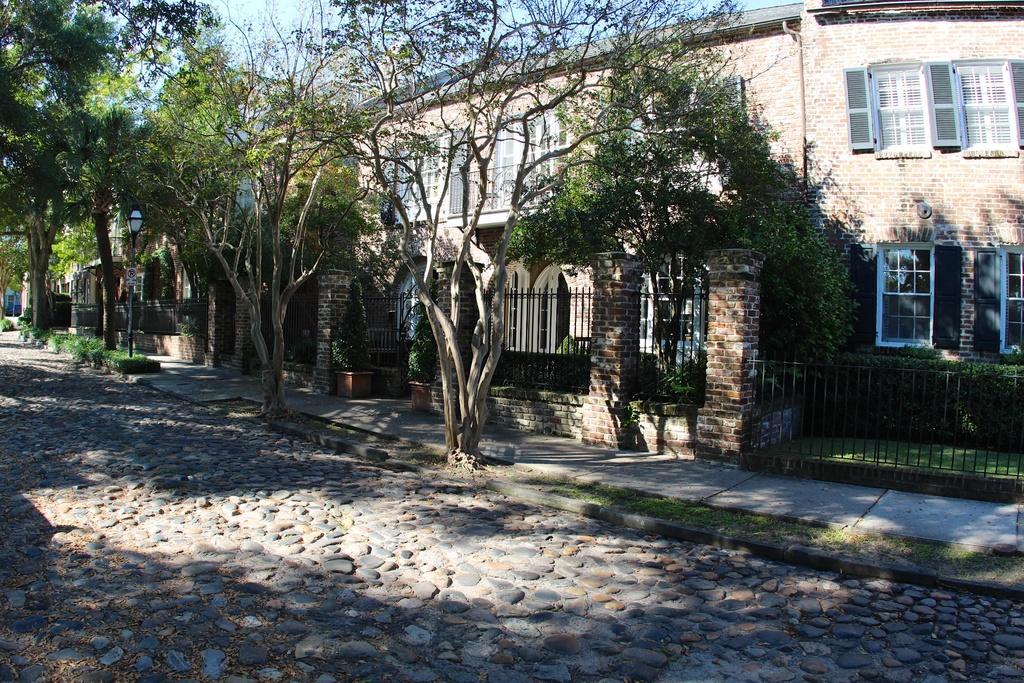Describe this image in one or two sentences. In this image I can see a pebble road in the front. There are trees, fence and a building at the back. There is sky at the top. 